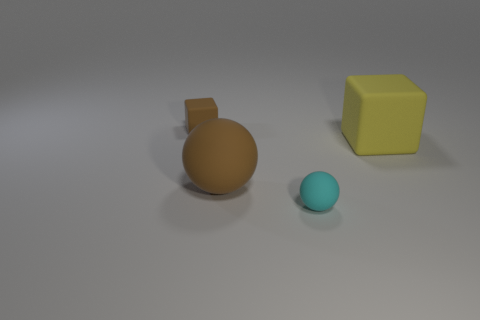What number of gray cylinders are there?
Your answer should be very brief. 0. The block that is left of the small cyan sphere in front of the yellow matte thing is made of what material?
Offer a terse response. Rubber. The small object in front of the large matte object that is on the right side of the rubber ball in front of the large brown ball is what color?
Provide a short and direct response. Cyan. Is the color of the tiny cube the same as the large matte sphere?
Offer a very short reply. Yes. What number of other matte cubes are the same size as the brown cube?
Your answer should be compact. 0. Is the number of large yellow blocks that are behind the tiny brown matte cube greater than the number of brown rubber cubes to the right of the yellow rubber object?
Offer a terse response. No. The tiny matte object that is in front of the big rubber object right of the cyan object is what color?
Your answer should be compact. Cyan. Is there another thing of the same shape as the large yellow object?
Offer a very short reply. Yes. Is the color of the tiny rubber thing behind the yellow rubber object the same as the tiny matte ball?
Provide a short and direct response. No. There is a cube to the right of the small cyan matte object; is it the same size as the block on the left side of the tiny cyan sphere?
Your response must be concise. No. 